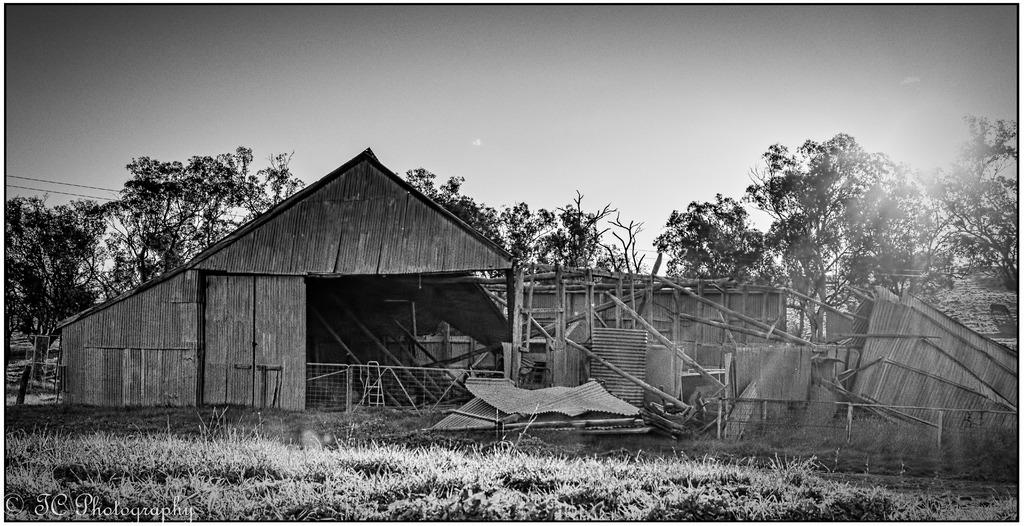What is the color scheme of the image? The image is black and white. What type of house can be seen in the image? There is a wooden house in the image. What type of vegetation is present in the image? There are trees and grass in the image. What can be seen in the background of the image? The sky is visible in the background of the image. Where is the hen located in the image? There is no hen present in the image. Is there a railway visible in the image? There is no railway present in the image. 